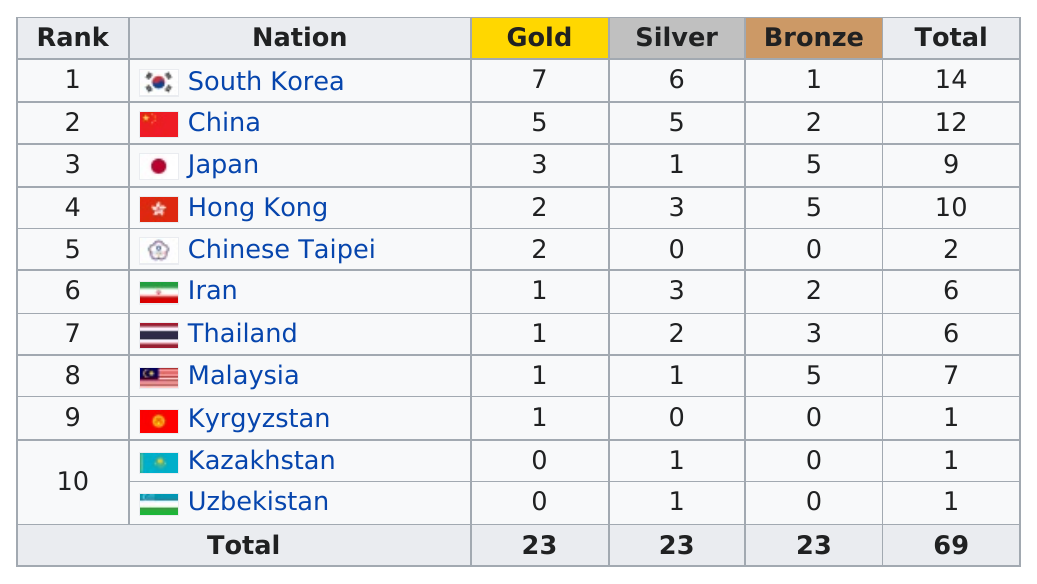Give some essential details in this illustration. The number of teams that won at least three bronze medals in this event is four. South Korea was ranked first in this event. In total, Japan was awarded 9 medals. Out of the 2 teams that did not win any gold medals in this event, 2 teams did not win any gold medals in this event. China received a total of 10 gold and silver medals. 